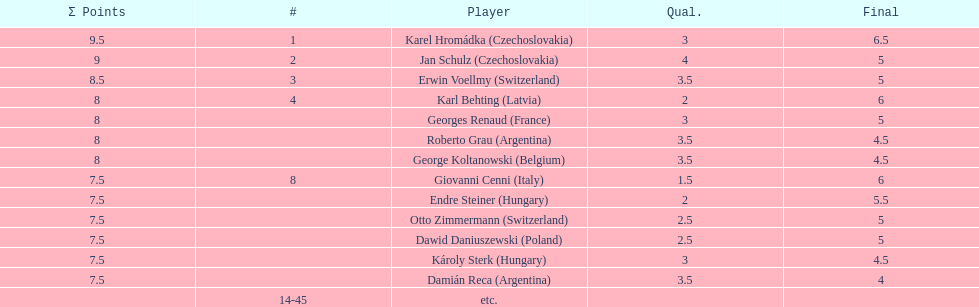Karl behting and giovanni cenni each had final scores of what? 6. 